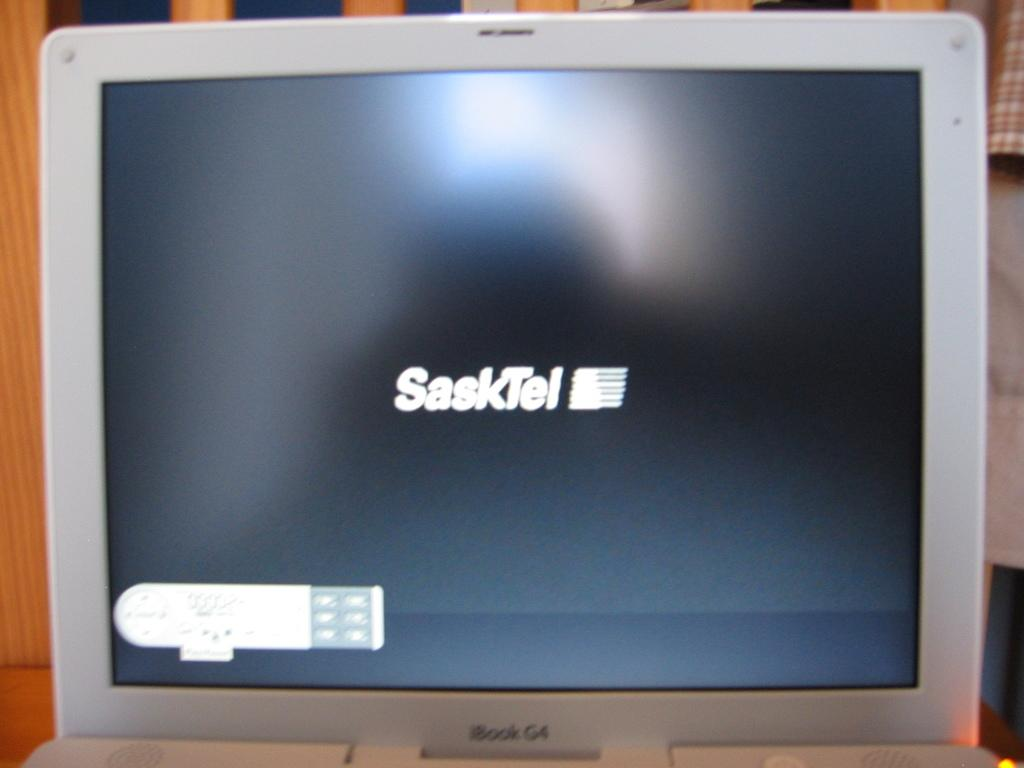Provide a one-sentence caption for the provided image. An iBook G4 laptop, displaying the SaskTel logo. 